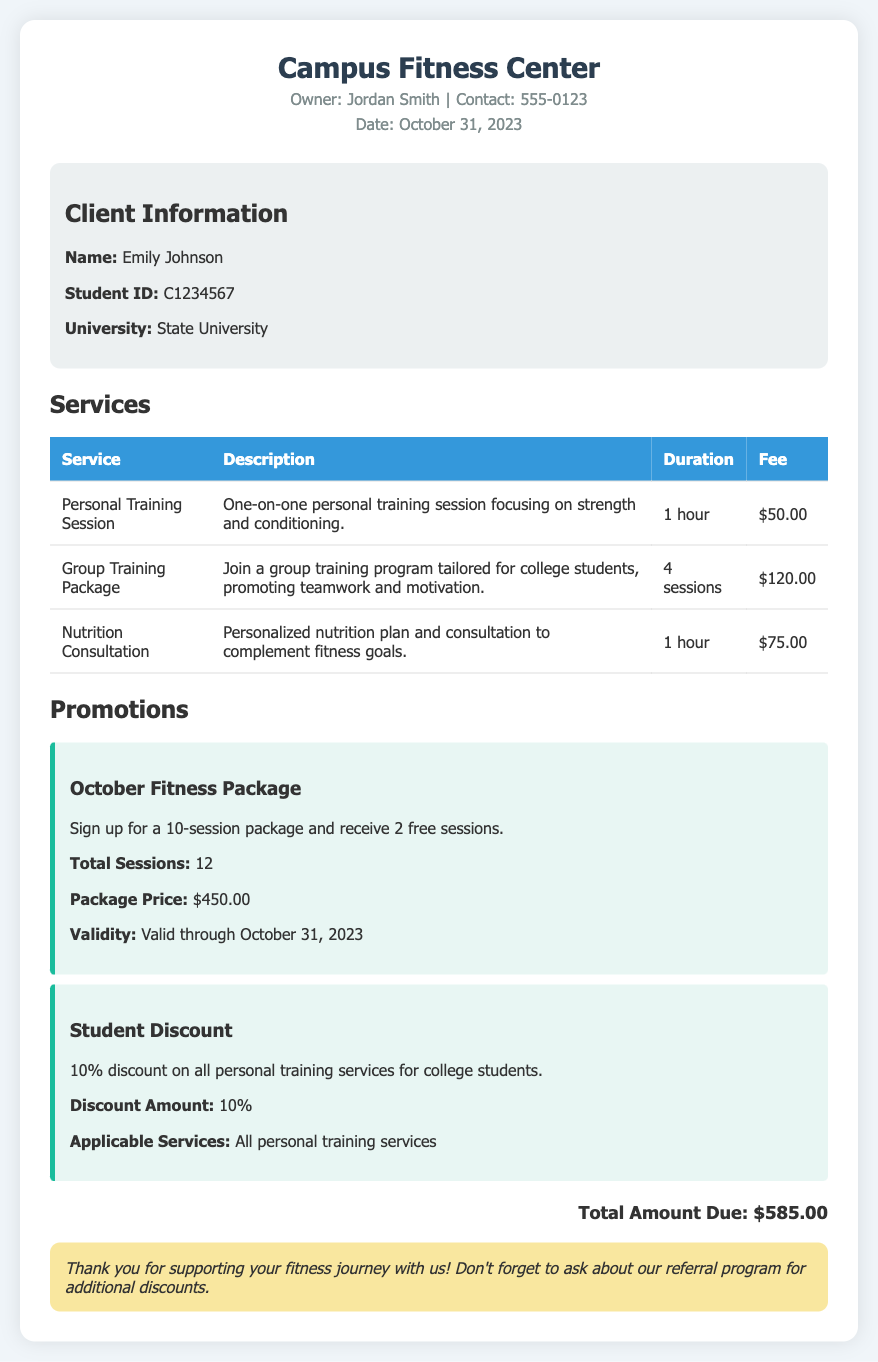What is the name of the client? The client's name is specified in the client information section of the document.
Answer: Emily Johnson What is the fee for a one-on-one personal training session? The fee for a personal training session is listed in the services table.
Answer: $50.00 How many sessions are included in the October Fitness Package? The total number of sessions included in the promotional package is noted in the promotions section.
Answer: 12 What discount is offered to college students on personal training services? The discount given to college students is mentioned in the promotions section.
Answer: 10% What is the total amount due? The total amount due is stated at the bottom of the document.
Answer: $585.00 What is the owner's name of the fitness center? The owner's name is provided in the header of the document.
Answer: Jordan Smith How long does a nutrition consultation last? The duration of the nutrition consultation is mentioned in the services table.
Answer: 1 hour What is the package price for the October Fitness Package? The package price is specified in the promotions section of the document.
Answer: $450.00 What type of service is offered in the group training package? The type of service for the group training package is outlined in the services table.
Answer: Group training program 